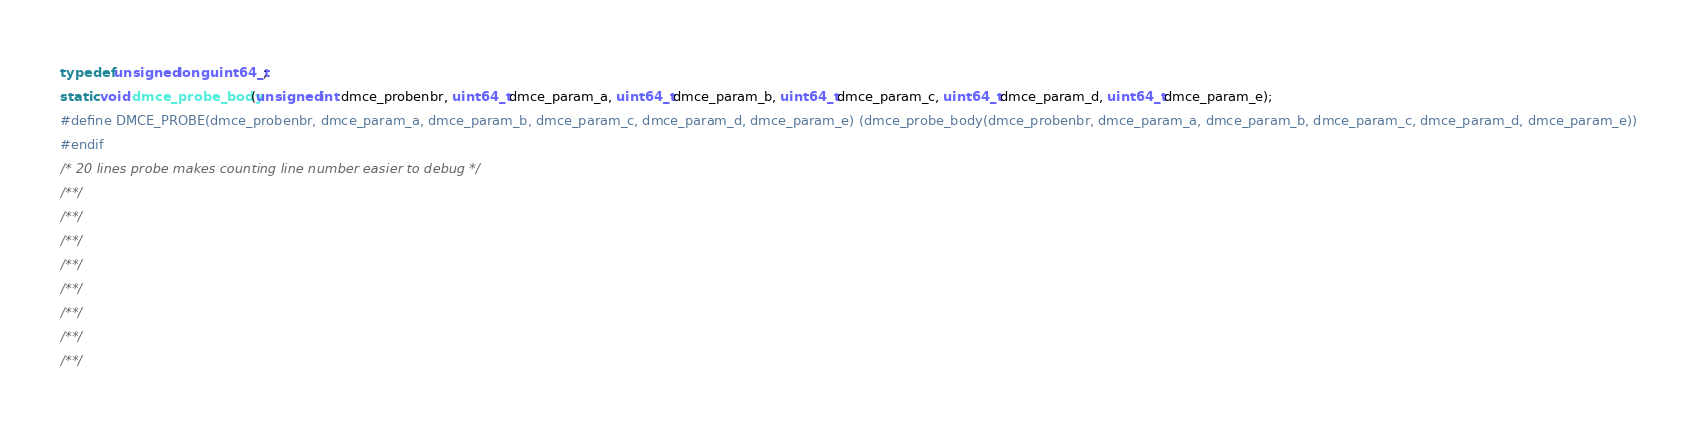<code> <loc_0><loc_0><loc_500><loc_500><_C_>typedef unsigned long uint64_t;
static void dmce_probe_body(unsigned int dmce_probenbr, uint64_t dmce_param_a, uint64_t dmce_param_b, uint64_t dmce_param_c, uint64_t dmce_param_d, uint64_t dmce_param_e);
#define DMCE_PROBE(dmce_probenbr, dmce_param_a, dmce_param_b, dmce_param_c, dmce_param_d, dmce_param_e) (dmce_probe_body(dmce_probenbr, dmce_param_a, dmce_param_b, dmce_param_c, dmce_param_d, dmce_param_e))
#endif
/* 20 lines probe makes counting line number easier to debug */
/**/
/**/
/**/
/**/
/**/
/**/
/**/
/**/
</code> 